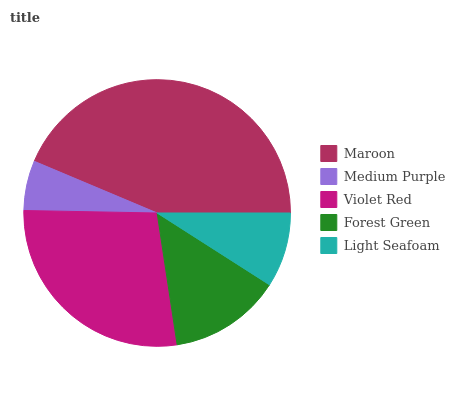Is Medium Purple the minimum?
Answer yes or no. Yes. Is Maroon the maximum?
Answer yes or no. Yes. Is Violet Red the minimum?
Answer yes or no. No. Is Violet Red the maximum?
Answer yes or no. No. Is Violet Red greater than Medium Purple?
Answer yes or no. Yes. Is Medium Purple less than Violet Red?
Answer yes or no. Yes. Is Medium Purple greater than Violet Red?
Answer yes or no. No. Is Violet Red less than Medium Purple?
Answer yes or no. No. Is Forest Green the high median?
Answer yes or no. Yes. Is Forest Green the low median?
Answer yes or no. Yes. Is Violet Red the high median?
Answer yes or no. No. Is Violet Red the low median?
Answer yes or no. No. 